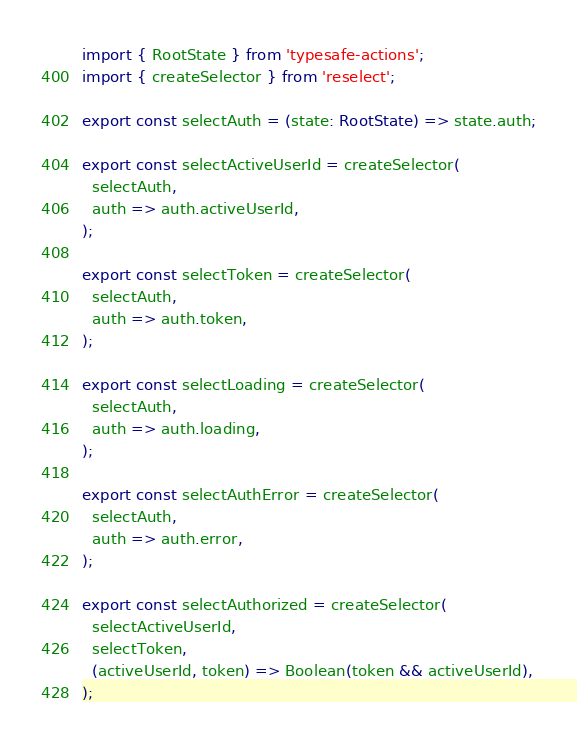Convert code to text. <code><loc_0><loc_0><loc_500><loc_500><_TypeScript_>import { RootState } from 'typesafe-actions';
import { createSelector } from 'reselect';

export const selectAuth = (state: RootState) => state.auth;

export const selectActiveUserId = createSelector(
  selectAuth,
  auth => auth.activeUserId,
);

export const selectToken = createSelector(
  selectAuth,
  auth => auth.token,
);

export const selectLoading = createSelector(
  selectAuth,
  auth => auth.loading,
);

export const selectAuthError = createSelector(
  selectAuth,
  auth => auth.error,
);

export const selectAuthorized = createSelector(
  selectActiveUserId,
  selectToken,
  (activeUserId, token) => Boolean(token && activeUserId),
);
</code> 